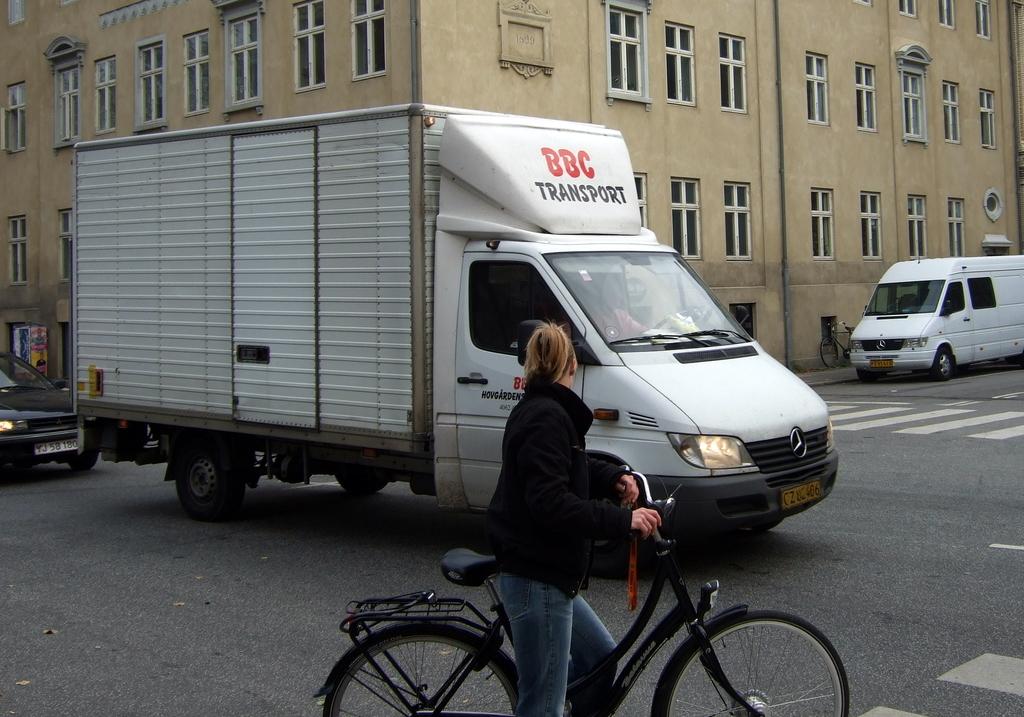What is the name of the transport company?
Offer a very short reply. Bbc. 